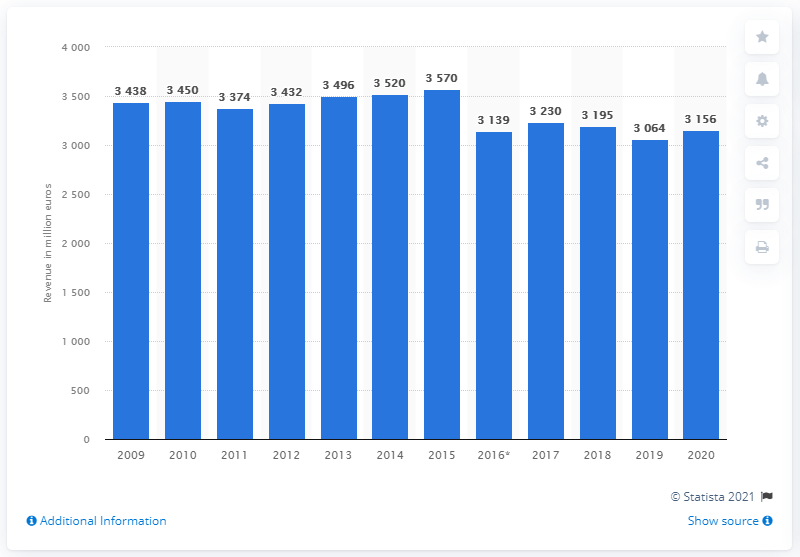Indicate a few pertinent items in this graphic. Nestlé generated approximately 3,195 million euros in Germany in 2020. 